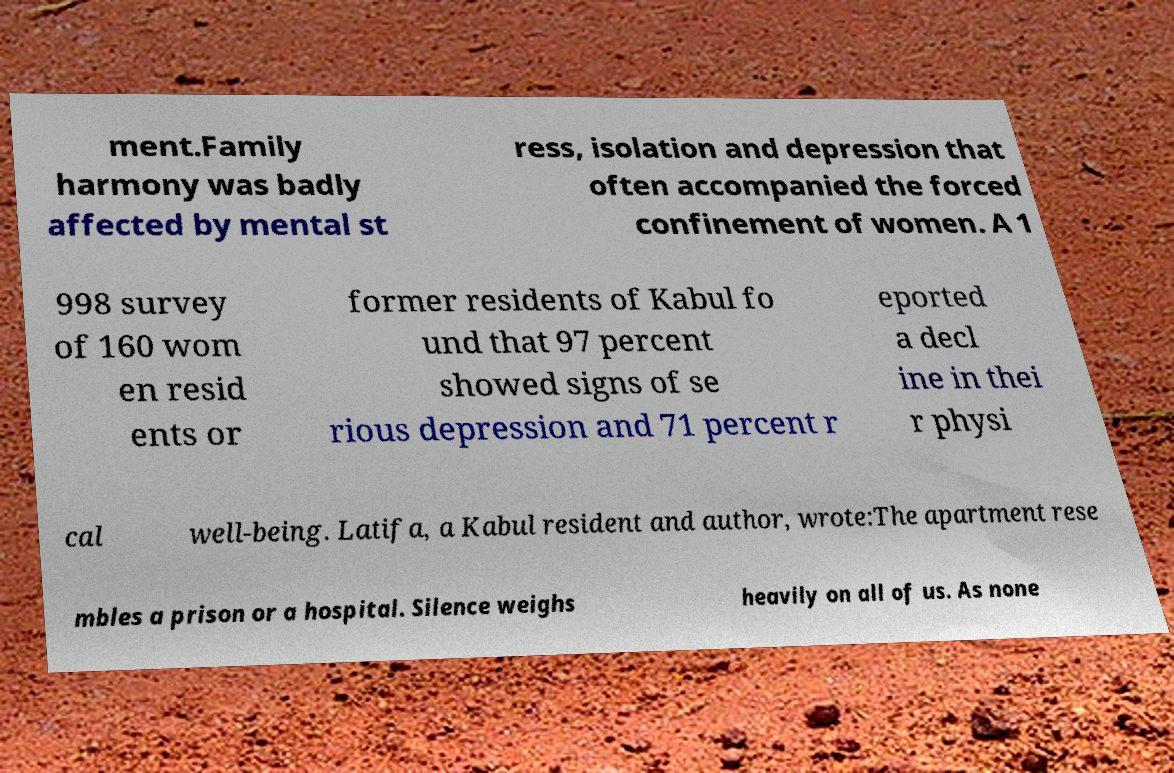Can you read and provide the text displayed in the image?This photo seems to have some interesting text. Can you extract and type it out for me? ment.Family harmony was badly affected by mental st ress, isolation and depression that often accompanied the forced confinement of women. A 1 998 survey of 160 wom en resid ents or former residents of Kabul fo und that 97 percent showed signs of se rious depression and 71 percent r eported a decl ine in thei r physi cal well-being. Latifa, a Kabul resident and author, wrote:The apartment rese mbles a prison or a hospital. Silence weighs heavily on all of us. As none 